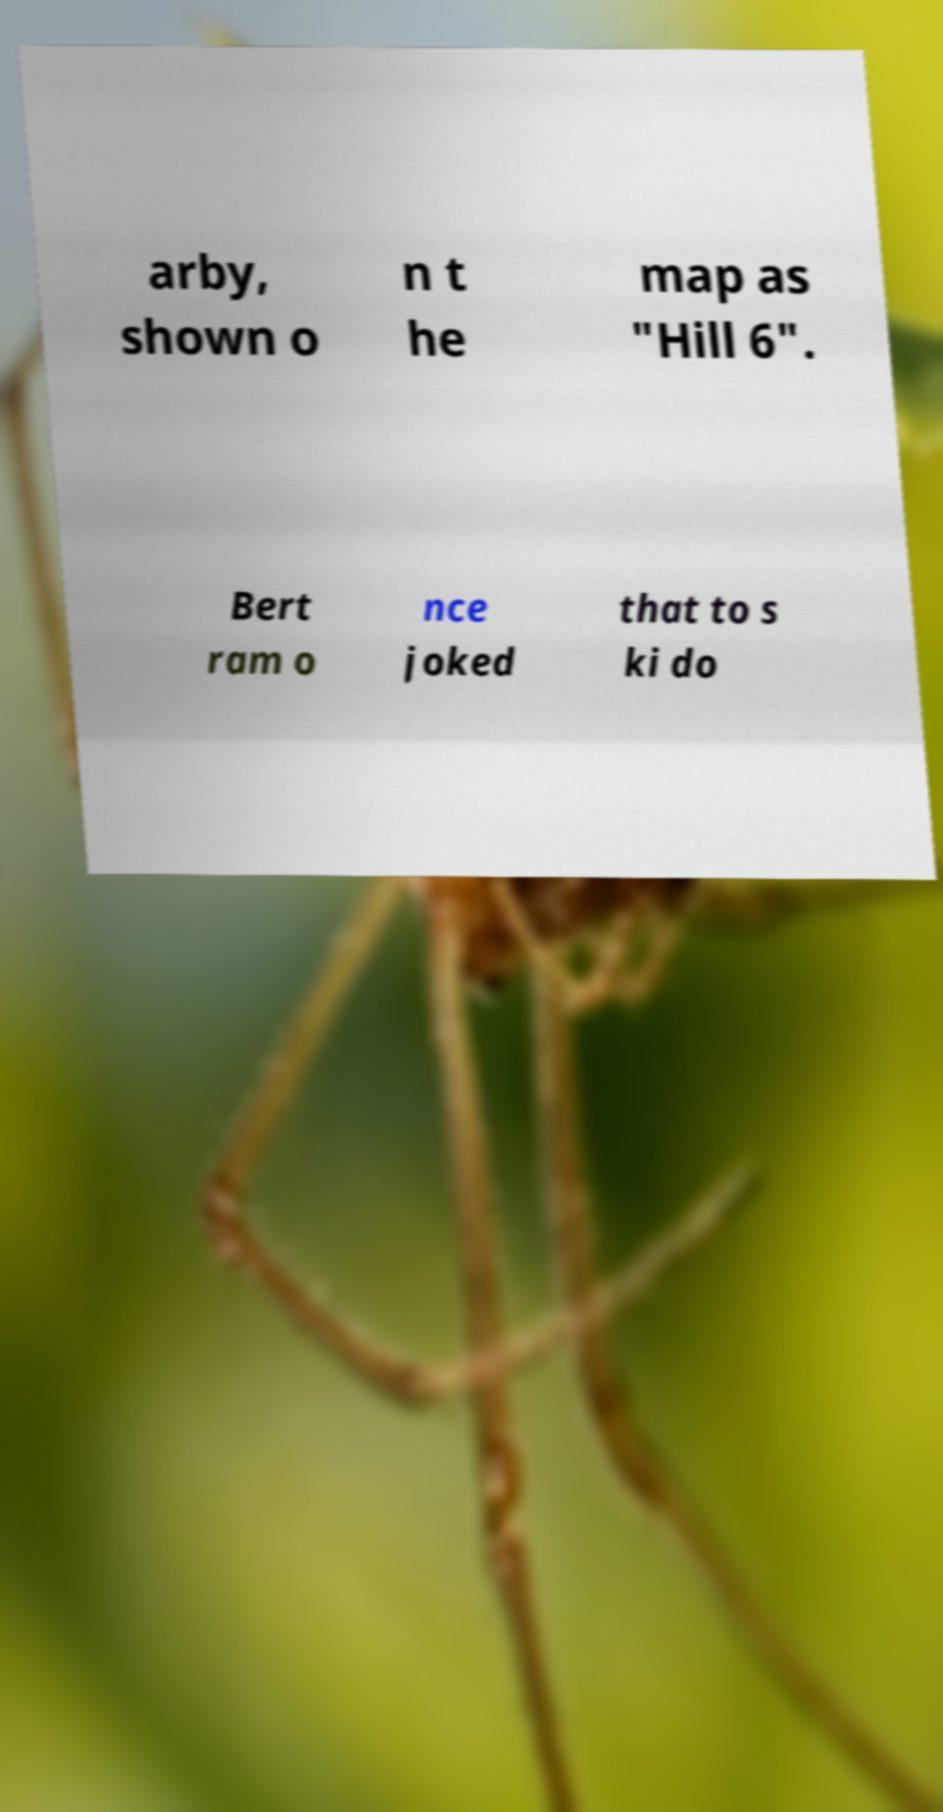Can you accurately transcribe the text from the provided image for me? arby, shown o n t he map as "Hill 6". Bert ram o nce joked that to s ki do 